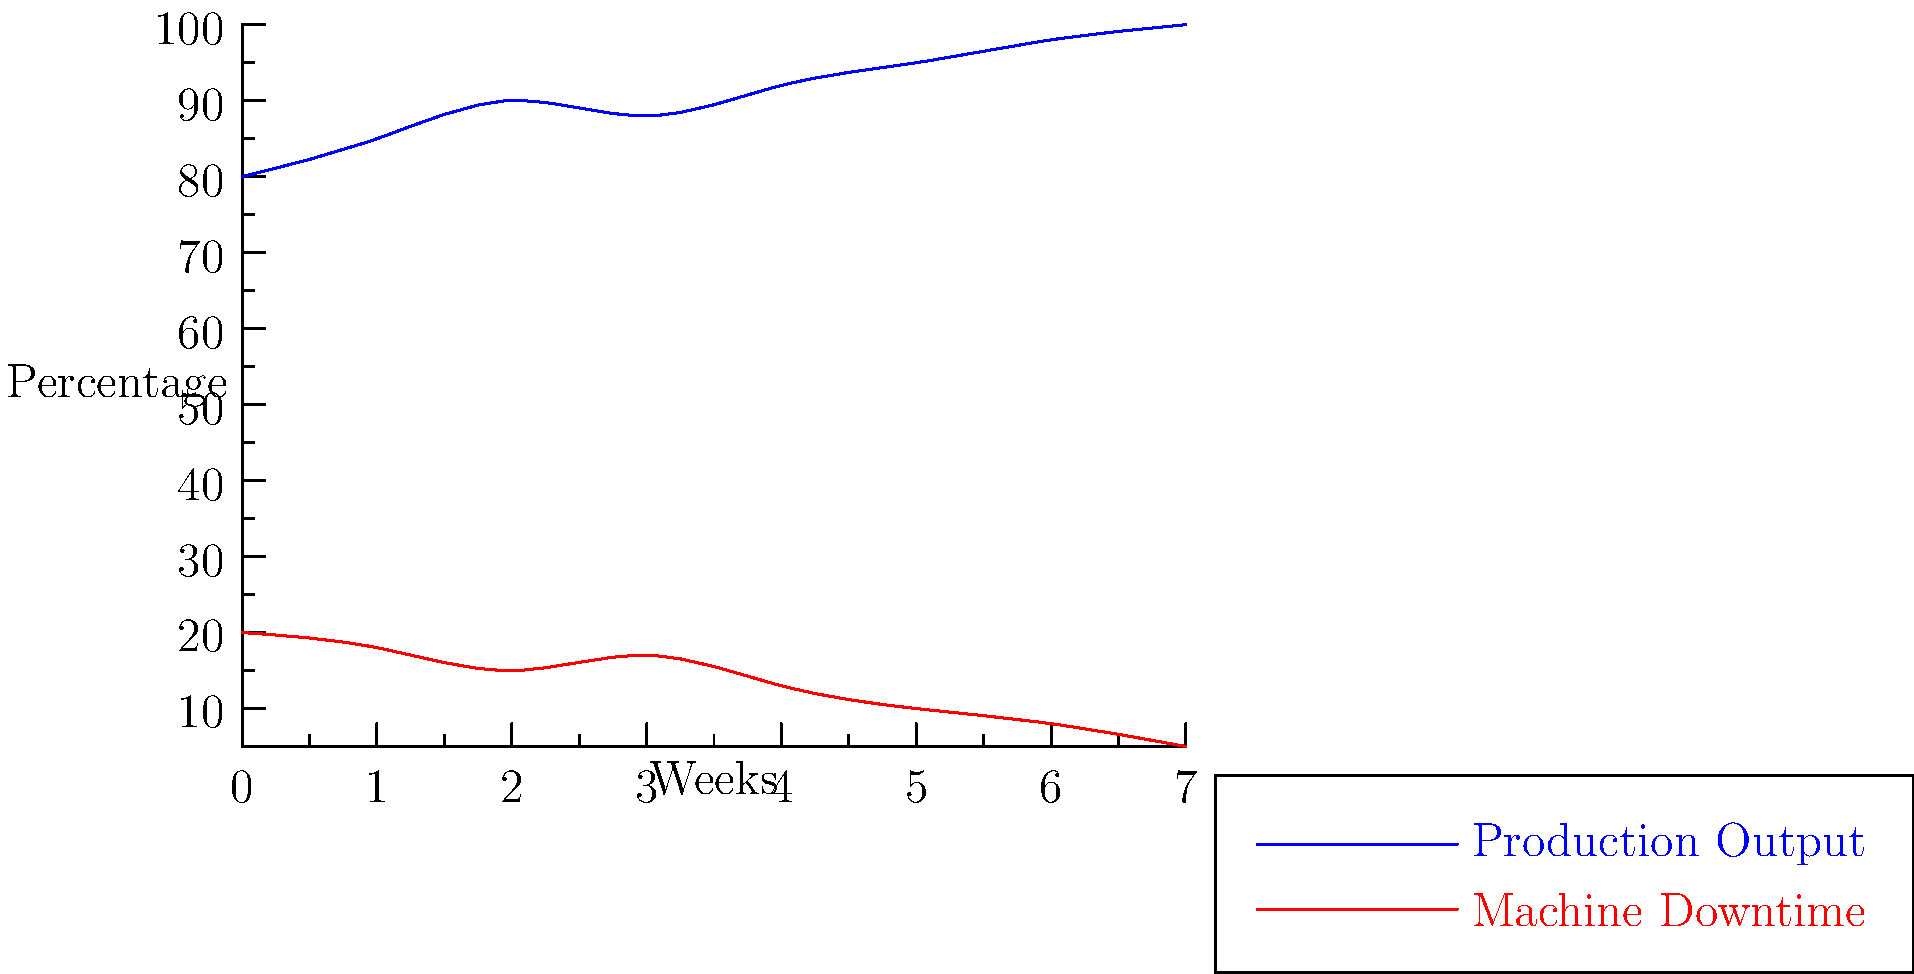Based on the multi-line graph showing production output and machine downtime over 8 weeks, what is the relationship between these two metrics, and what conclusion can be drawn about the efficiency of the production line? To answer this question, we need to analyze the trends in both production output and machine downtime:

1. Production Output (blue line):
   - Starts at about 80% in week 0
   - Shows a general upward trend
   - Reaches 100% by week 7

2. Machine Downtime (red line):
   - Starts at about 20% in week 0
   - Shows a general downward trend
   - Decreases to about 5% by week 7

3. Relationship between the two metrics:
   - As production output increases, machine downtime decreases
   - There is an inverse relationship between the two metrics

4. Efficiency conclusion:
   - The inverse relationship suggests that reduced machine downtime is contributing to increased production output
   - The production line is becoming more efficient over time, as evidenced by the increasing output and decreasing downtime

Therefore, we can conclude that the production line's efficiency is improving over the 8-week period, with machine downtime reduction playing a significant role in boosting production output.
Answer: Inverse relationship; improving efficiency 